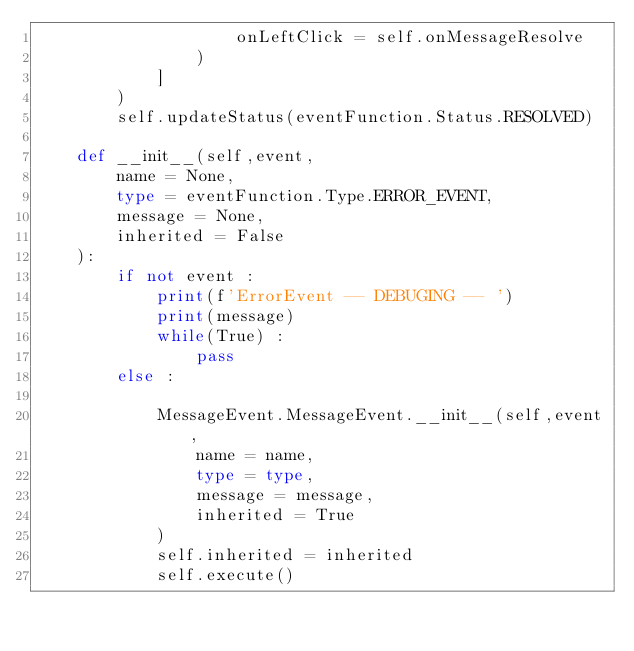Convert code to text. <code><loc_0><loc_0><loc_500><loc_500><_Python_>                    onLeftClick = self.onMessageResolve
                )
            ]
        )
        self.updateStatus(eventFunction.Status.RESOLVED)

    def __init__(self,event,
        name = None,
        type = eventFunction.Type.ERROR_EVENT,
        message = None,
        inherited = False
    ):
        if not event :
            print(f'ErrorEvent -- DEBUGING -- ')
            print(message)
            while(True) :
                pass
        else :

            MessageEvent.MessageEvent.__init__(self,event,
                name = name,
                type = type,
                message = message,
                inherited = True
            )
            self.inherited = inherited
            self.execute()
</code> 